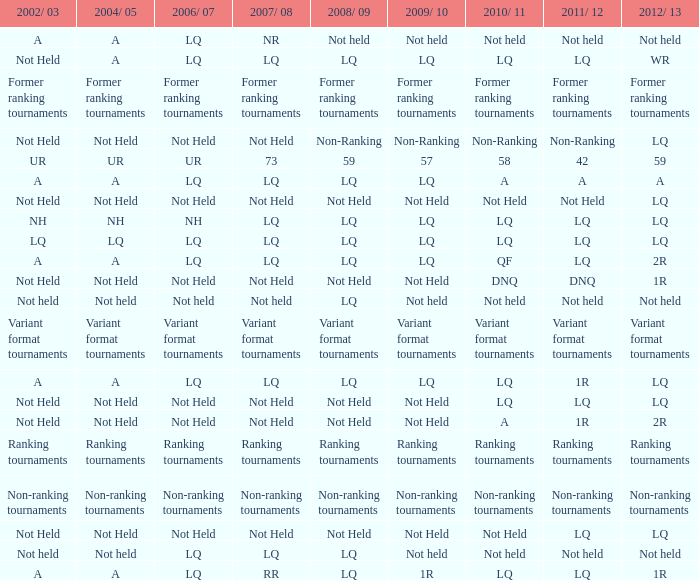Name the 2008/09 with 2004/05 of ranking tournaments Ranking tournaments. 